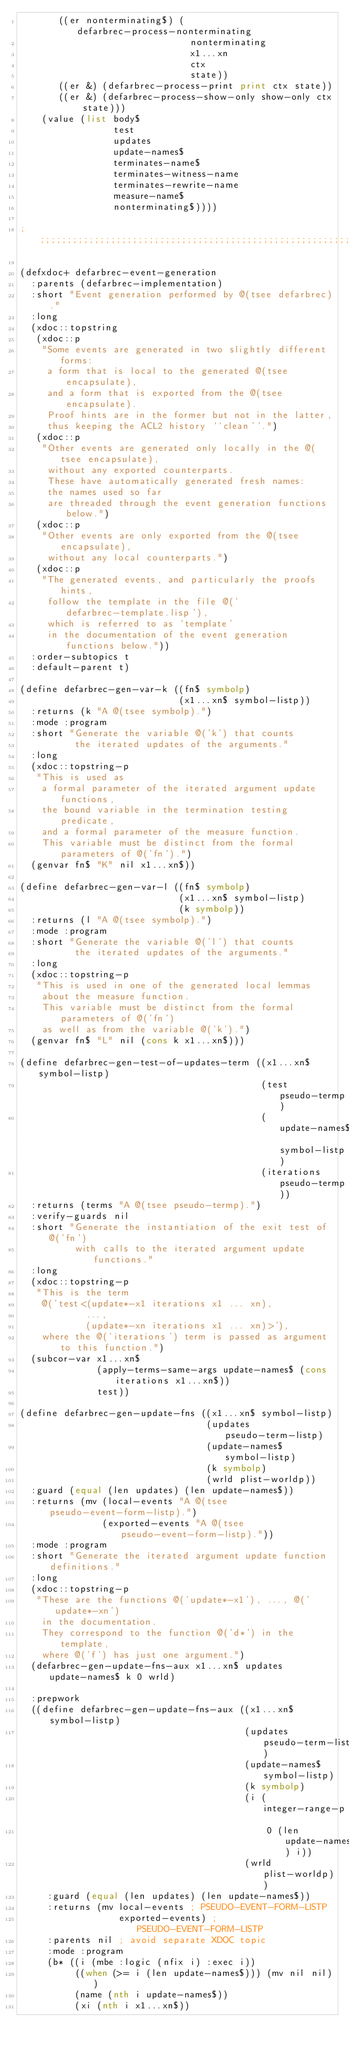Convert code to text. <code><loc_0><loc_0><loc_500><loc_500><_Lisp_>       ((er nonterminating$) (defarbrec-process-nonterminating
                               nonterminating
                               x1...xn
                               ctx
                               state))
       ((er &) (defarbrec-process-print print ctx state))
       ((er &) (defarbrec-process-show-only show-only ctx state)))
    (value (list body$
                 test
                 updates
                 update-names$
                 terminates-name$
                 terminates-witness-name
                 terminates-rewrite-name
                 measure-name$
                 nonterminating$))))

;;;;;;;;;;;;;;;;;;;;;;;;;;;;;;;;;;;;;;;;;;;;;;;;;;;;;;;;;;;;;;;;;;;;;;;;;;;;;;;;

(defxdoc+ defarbrec-event-generation
  :parents (defarbrec-implementation)
  :short "Event generation performed by @(tsee defarbrec)."
  :long
  (xdoc::topstring
   (xdoc::p
    "Some events are generated in two slightly different forms:
     a form that is local to the generated @(tsee encapsulate),
     and a form that is exported from the @(tsee encapsulate).
     Proof hints are in the former but not in the latter,
     thus keeping the ACL2 history ``clean''.")
   (xdoc::p
    "Other events are generated only locally in the @(tsee encapsulate),
     without any exported counterparts.
     These have automatically generated fresh names:
     the names used so far
     are threaded through the event generation functions below.")
   (xdoc::p
    "Other events are only exported from the @(tsee encapsulate),
     without any local counterparts.")
   (xdoc::p
    "The generated events, and particularly the proofs hints,
     follow the template in the file @('defarbrec-template.lisp'),
     which is referred to as `template'
     in the documentation of the event generation functions below."))
  :order-subtopics t
  :default-parent t)

(define defarbrec-gen-var-k ((fn$ symbolp)
                             (x1...xn$ symbol-listp))
  :returns (k "A @(tsee symbolp).")
  :mode :program
  :short "Generate the variable @('k') that counts
          the iterated updates of the arguments."
  :long
  (xdoc::topstring-p
   "This is used as
    a formal parameter of the iterated argument update functions,
    the bound variable in the termination testing predicate,
    and a formal parameter of the measure function.
    This variable must be distinct from the formal parameters of @('fn').")
  (genvar fn$ "K" nil x1...xn$))

(define defarbrec-gen-var-l ((fn$ symbolp)
                             (x1...xn$ symbol-listp)
                             (k symbolp))
  :returns (l "A @(tsee symbolp).")
  :mode :program
  :short "Generate the variable @('l') that counts
          the iterated updates of the arguments."
  :long
  (xdoc::topstring-p
   "This is used in one of the generated local lemmas
    about the measure function.
    This variable must be distinct from the formal parameters of @('fn')
    as well as from the variable @('k').")
  (genvar fn$ "L" nil (cons k x1...xn$)))

(define defarbrec-gen-test-of-updates-term ((x1...xn$ symbol-listp)
                                            (test pseudo-termp)
                                            (update-names$ symbol-listp)
                                            (iterations pseudo-termp))
  :returns (terms "A @(tsee pseudo-termp).")
  :verify-guards nil
  :short "Generate the instantiation of the exit test of @('fn')
          with calls to the iterated argument update functions."
  :long
  (xdoc::topstring-p
   "This is the term
    @('test<(update*-x1 iterations x1 ... xn),
            ...,
            (update*-xn iterations x1 ... xn)>'),
    where the @('iterations') term is passed as argument to this function.")
  (subcor-var x1...xn$
              (apply-terms-same-args update-names$ (cons iterations x1...xn$))
              test))

(define defarbrec-gen-update-fns ((x1...xn$ symbol-listp)
                                  (updates pseudo-term-listp)
                                  (update-names$ symbol-listp)
                                  (k symbolp)
                                  (wrld plist-worldp))
  :guard (equal (len updates) (len update-names$))
  :returns (mv (local-events "A @(tsee pseudo-event-form-listp).")
               (exported-events "A @(tsee pseudo-event-form-listp)."))
  :mode :program
  :short "Generate the iterated argument update function definitions."
  :long
  (xdoc::topstring-p
   "These are the functions @('update*-x1'), ..., @('update*-xn')
    in the documentation.
    They correspond to the function @('d*') in the template,
    where @('f') has just one argument.")
  (defarbrec-gen-update-fns-aux x1...xn$ updates update-names$ k 0 wrld)

  :prepwork
  ((define defarbrec-gen-update-fns-aux ((x1...xn$ symbol-listp)
                                         (updates pseudo-term-listp)
                                         (update-names$ symbol-listp)
                                         (k symbolp)
                                         (i (integer-range-p
                                             0 (len update-names$) i))
                                         (wrld plist-worldp))
     :guard (equal (len updates) (len update-names$))
     :returns (mv local-events ; PSEUDO-EVENT-FORM-LISTP
                  exported-events) ; PSEUDO-EVENT-FORM-LISTP
     :parents nil ; avoid separate XDOC topic
     :mode :program
     (b* ((i (mbe :logic (nfix i) :exec i))
          ((when (>= i (len update-names$))) (mv nil nil))
          (name (nth i update-names$))
          (xi (nth i x1...xn$))</code> 